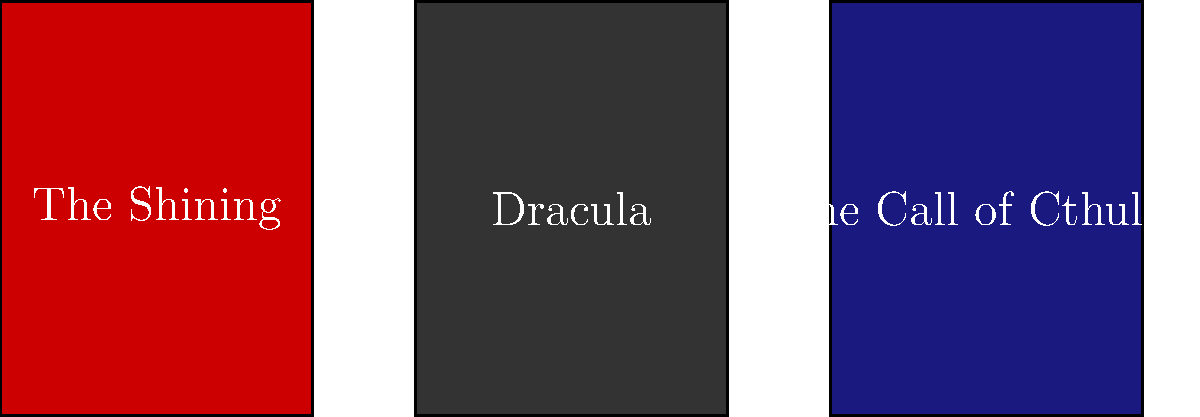Based on the visual representations of these iconic book covers, identify the authors associated with each work. Which of these authors is known for incorporating cosmic horror and the fear of the unknown into their stories? To answer this question, let's analyze each book cover and its associated author:

1. "The Shining": This is a famous novel by Stephen King, known for his psychological horror and supernatural themes.

2. "Dracula": This classic gothic horror novel was written by Bram Stoker, focusing on vampires and Victorian-era fears.

3. "The Call of Cthulhu": This is one of the most famous works by H.P. Lovecraft, who is renowned for his cosmic horror and stories about the fear of the unknown.

Among these three authors, H.P. Lovecraft is particularly known for incorporating cosmic horror and the fear of the unknown into his stories. His works often feature ancient, otherworldly beings that are beyond human comprehension, creating a sense of existential dread and insignificance in the face of the vast, uncaring universe.

Lovecraft's stories typically involve characters encountering forces or entities that are so alien and powerful that merely perceiving them can drive a person insane. This approach to horror focuses on the psychological impact of confronting the unknown and unknowable, rather than relying on more traditional horror elements like ghosts or monsters.

While Stephen King and Bram Stoker have made significant contributions to horror literature, their works generally do not focus on cosmic horror or the fear of the unknown to the same extent as Lovecraft's.
Answer: H.P. Lovecraft 